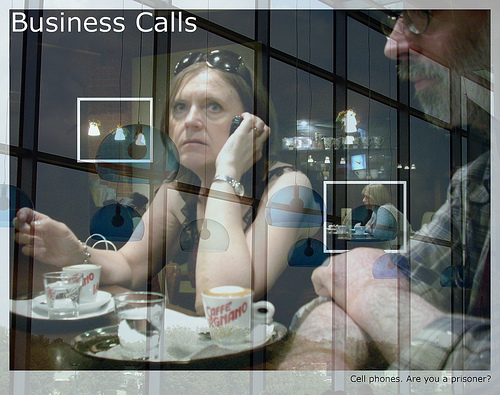What is the person to the right of the coffee cup wearing? The person to the right of the coffee cup is wearing glasses. 